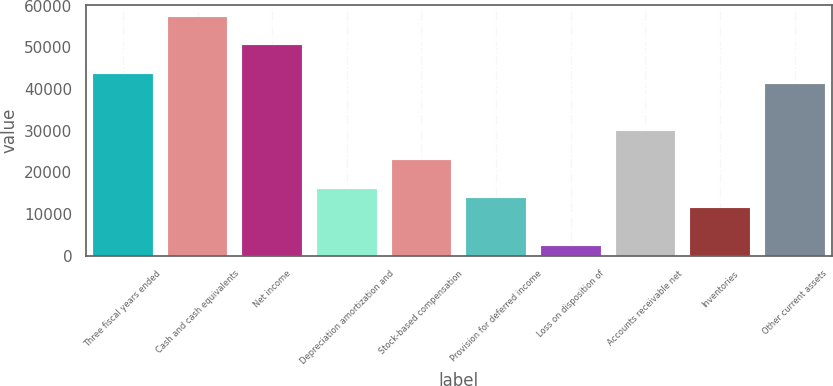Convert chart to OTSL. <chart><loc_0><loc_0><loc_500><loc_500><bar_chart><fcel>Three fiscal years ended<fcel>Cash and cash equivalents<fcel>Net income<fcel>Depreciation amortization and<fcel>Stock-based compensation<fcel>Provision for deferred income<fcel>Loss on disposition of<fcel>Accounts receivable net<fcel>Inventories<fcel>Other current assets<nl><fcel>43624.5<fcel>57397.5<fcel>50511<fcel>16078.5<fcel>22965<fcel>13783<fcel>2305.5<fcel>29851.5<fcel>11487.5<fcel>41329<nl></chart> 